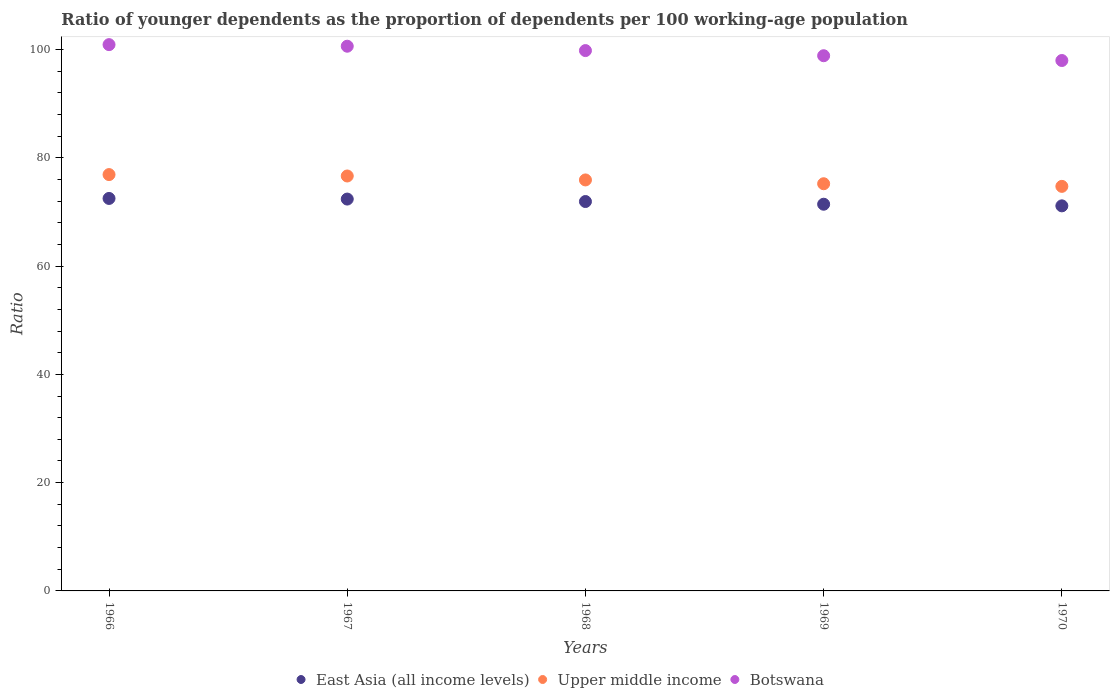Is the number of dotlines equal to the number of legend labels?
Your answer should be very brief. Yes. What is the age dependency ratio(young) in Botswana in 1969?
Your answer should be compact. 98.85. Across all years, what is the maximum age dependency ratio(young) in Botswana?
Your response must be concise. 100.9. Across all years, what is the minimum age dependency ratio(young) in East Asia (all income levels)?
Provide a succinct answer. 71.12. In which year was the age dependency ratio(young) in Upper middle income maximum?
Provide a short and direct response. 1966. In which year was the age dependency ratio(young) in East Asia (all income levels) minimum?
Your answer should be compact. 1970. What is the total age dependency ratio(young) in Botswana in the graph?
Your response must be concise. 498.14. What is the difference between the age dependency ratio(young) in Botswana in 1967 and that in 1970?
Ensure brevity in your answer.  2.64. What is the difference between the age dependency ratio(young) in East Asia (all income levels) in 1967 and the age dependency ratio(young) in Upper middle income in 1970?
Make the answer very short. -2.35. What is the average age dependency ratio(young) in East Asia (all income levels) per year?
Give a very brief answer. 71.87. In the year 1970, what is the difference between the age dependency ratio(young) in East Asia (all income levels) and age dependency ratio(young) in Botswana?
Offer a terse response. -26.85. In how many years, is the age dependency ratio(young) in Upper middle income greater than 28?
Your response must be concise. 5. What is the ratio of the age dependency ratio(young) in East Asia (all income levels) in 1967 to that in 1968?
Provide a short and direct response. 1.01. What is the difference between the highest and the second highest age dependency ratio(young) in East Asia (all income levels)?
Provide a succinct answer. 0.12. What is the difference between the highest and the lowest age dependency ratio(young) in East Asia (all income levels)?
Your answer should be compact. 1.37. Is the sum of the age dependency ratio(young) in East Asia (all income levels) in 1966 and 1970 greater than the maximum age dependency ratio(young) in Botswana across all years?
Provide a short and direct response. Yes. Is it the case that in every year, the sum of the age dependency ratio(young) in Upper middle income and age dependency ratio(young) in Botswana  is greater than the age dependency ratio(young) in East Asia (all income levels)?
Make the answer very short. Yes. How many dotlines are there?
Provide a succinct answer. 3. How many years are there in the graph?
Offer a very short reply. 5. What is the difference between two consecutive major ticks on the Y-axis?
Your response must be concise. 20. Does the graph contain grids?
Give a very brief answer. No. Where does the legend appear in the graph?
Make the answer very short. Bottom center. How are the legend labels stacked?
Give a very brief answer. Horizontal. What is the title of the graph?
Your response must be concise. Ratio of younger dependents as the proportion of dependents per 100 working-age population. Does "Dominican Republic" appear as one of the legend labels in the graph?
Offer a terse response. No. What is the label or title of the X-axis?
Your answer should be very brief. Years. What is the label or title of the Y-axis?
Offer a terse response. Ratio. What is the Ratio of East Asia (all income levels) in 1966?
Offer a very short reply. 72.49. What is the Ratio in Upper middle income in 1966?
Ensure brevity in your answer.  76.9. What is the Ratio of Botswana in 1966?
Your answer should be compact. 100.9. What is the Ratio in East Asia (all income levels) in 1967?
Make the answer very short. 72.38. What is the Ratio in Upper middle income in 1967?
Your response must be concise. 76.64. What is the Ratio in Botswana in 1967?
Provide a succinct answer. 100.61. What is the Ratio in East Asia (all income levels) in 1968?
Your answer should be compact. 71.92. What is the Ratio in Upper middle income in 1968?
Give a very brief answer. 75.91. What is the Ratio of Botswana in 1968?
Ensure brevity in your answer.  99.8. What is the Ratio in East Asia (all income levels) in 1969?
Your response must be concise. 71.43. What is the Ratio of Upper middle income in 1969?
Your answer should be compact. 75.21. What is the Ratio of Botswana in 1969?
Make the answer very short. 98.85. What is the Ratio in East Asia (all income levels) in 1970?
Give a very brief answer. 71.12. What is the Ratio of Upper middle income in 1970?
Your answer should be compact. 74.72. What is the Ratio of Botswana in 1970?
Provide a short and direct response. 97.97. Across all years, what is the maximum Ratio in East Asia (all income levels)?
Ensure brevity in your answer.  72.49. Across all years, what is the maximum Ratio of Upper middle income?
Make the answer very short. 76.9. Across all years, what is the maximum Ratio of Botswana?
Provide a succinct answer. 100.9. Across all years, what is the minimum Ratio in East Asia (all income levels)?
Your answer should be compact. 71.12. Across all years, what is the minimum Ratio of Upper middle income?
Provide a short and direct response. 74.72. Across all years, what is the minimum Ratio in Botswana?
Provide a short and direct response. 97.97. What is the total Ratio in East Asia (all income levels) in the graph?
Your answer should be very brief. 359.34. What is the total Ratio in Upper middle income in the graph?
Your answer should be very brief. 379.38. What is the total Ratio in Botswana in the graph?
Provide a succinct answer. 498.14. What is the difference between the Ratio in East Asia (all income levels) in 1966 and that in 1967?
Offer a terse response. 0.12. What is the difference between the Ratio of Upper middle income in 1966 and that in 1967?
Offer a terse response. 0.26. What is the difference between the Ratio in Botswana in 1966 and that in 1967?
Provide a succinct answer. 0.29. What is the difference between the Ratio in East Asia (all income levels) in 1966 and that in 1968?
Make the answer very short. 0.57. What is the difference between the Ratio in Upper middle income in 1966 and that in 1968?
Your response must be concise. 0.99. What is the difference between the Ratio of Botswana in 1966 and that in 1968?
Make the answer very short. 1.1. What is the difference between the Ratio in East Asia (all income levels) in 1966 and that in 1969?
Your answer should be very brief. 1.07. What is the difference between the Ratio in Upper middle income in 1966 and that in 1969?
Give a very brief answer. 1.69. What is the difference between the Ratio in Botswana in 1966 and that in 1969?
Ensure brevity in your answer.  2.05. What is the difference between the Ratio in East Asia (all income levels) in 1966 and that in 1970?
Your answer should be very brief. 1.37. What is the difference between the Ratio in Upper middle income in 1966 and that in 1970?
Keep it short and to the point. 2.18. What is the difference between the Ratio of Botswana in 1966 and that in 1970?
Your response must be concise. 2.93. What is the difference between the Ratio of East Asia (all income levels) in 1967 and that in 1968?
Your response must be concise. 0.45. What is the difference between the Ratio of Upper middle income in 1967 and that in 1968?
Your response must be concise. 0.73. What is the difference between the Ratio of Botswana in 1967 and that in 1968?
Offer a terse response. 0.81. What is the difference between the Ratio in East Asia (all income levels) in 1967 and that in 1969?
Provide a succinct answer. 0.95. What is the difference between the Ratio of Upper middle income in 1967 and that in 1969?
Offer a very short reply. 1.43. What is the difference between the Ratio in Botswana in 1967 and that in 1969?
Provide a succinct answer. 1.76. What is the difference between the Ratio of East Asia (all income levels) in 1967 and that in 1970?
Your response must be concise. 1.25. What is the difference between the Ratio in Upper middle income in 1967 and that in 1970?
Provide a succinct answer. 1.92. What is the difference between the Ratio in Botswana in 1967 and that in 1970?
Give a very brief answer. 2.64. What is the difference between the Ratio of East Asia (all income levels) in 1968 and that in 1969?
Offer a terse response. 0.5. What is the difference between the Ratio of Upper middle income in 1968 and that in 1969?
Your response must be concise. 0.7. What is the difference between the Ratio in Botswana in 1968 and that in 1969?
Offer a terse response. 0.95. What is the difference between the Ratio in East Asia (all income levels) in 1968 and that in 1970?
Provide a short and direct response. 0.8. What is the difference between the Ratio of Upper middle income in 1968 and that in 1970?
Your response must be concise. 1.19. What is the difference between the Ratio in Botswana in 1968 and that in 1970?
Your answer should be compact. 1.83. What is the difference between the Ratio of East Asia (all income levels) in 1969 and that in 1970?
Provide a succinct answer. 0.3. What is the difference between the Ratio of Upper middle income in 1969 and that in 1970?
Ensure brevity in your answer.  0.49. What is the difference between the Ratio in Botswana in 1969 and that in 1970?
Provide a succinct answer. 0.89. What is the difference between the Ratio of East Asia (all income levels) in 1966 and the Ratio of Upper middle income in 1967?
Provide a succinct answer. -4.15. What is the difference between the Ratio of East Asia (all income levels) in 1966 and the Ratio of Botswana in 1967?
Your answer should be compact. -28.12. What is the difference between the Ratio of Upper middle income in 1966 and the Ratio of Botswana in 1967?
Ensure brevity in your answer.  -23.71. What is the difference between the Ratio of East Asia (all income levels) in 1966 and the Ratio of Upper middle income in 1968?
Ensure brevity in your answer.  -3.42. What is the difference between the Ratio of East Asia (all income levels) in 1966 and the Ratio of Botswana in 1968?
Your response must be concise. -27.31. What is the difference between the Ratio of Upper middle income in 1966 and the Ratio of Botswana in 1968?
Your response must be concise. -22.9. What is the difference between the Ratio in East Asia (all income levels) in 1966 and the Ratio in Upper middle income in 1969?
Offer a terse response. -2.72. What is the difference between the Ratio in East Asia (all income levels) in 1966 and the Ratio in Botswana in 1969?
Your response must be concise. -26.36. What is the difference between the Ratio of Upper middle income in 1966 and the Ratio of Botswana in 1969?
Provide a short and direct response. -21.95. What is the difference between the Ratio in East Asia (all income levels) in 1966 and the Ratio in Upper middle income in 1970?
Your answer should be very brief. -2.23. What is the difference between the Ratio in East Asia (all income levels) in 1966 and the Ratio in Botswana in 1970?
Ensure brevity in your answer.  -25.48. What is the difference between the Ratio in Upper middle income in 1966 and the Ratio in Botswana in 1970?
Your answer should be very brief. -21.07. What is the difference between the Ratio in East Asia (all income levels) in 1967 and the Ratio in Upper middle income in 1968?
Offer a terse response. -3.53. What is the difference between the Ratio of East Asia (all income levels) in 1967 and the Ratio of Botswana in 1968?
Your response must be concise. -27.43. What is the difference between the Ratio in Upper middle income in 1967 and the Ratio in Botswana in 1968?
Offer a terse response. -23.16. What is the difference between the Ratio in East Asia (all income levels) in 1967 and the Ratio in Upper middle income in 1969?
Provide a short and direct response. -2.83. What is the difference between the Ratio in East Asia (all income levels) in 1967 and the Ratio in Botswana in 1969?
Your response must be concise. -26.48. What is the difference between the Ratio of Upper middle income in 1967 and the Ratio of Botswana in 1969?
Make the answer very short. -22.21. What is the difference between the Ratio of East Asia (all income levels) in 1967 and the Ratio of Upper middle income in 1970?
Offer a very short reply. -2.35. What is the difference between the Ratio of East Asia (all income levels) in 1967 and the Ratio of Botswana in 1970?
Make the answer very short. -25.59. What is the difference between the Ratio of Upper middle income in 1967 and the Ratio of Botswana in 1970?
Ensure brevity in your answer.  -21.33. What is the difference between the Ratio in East Asia (all income levels) in 1968 and the Ratio in Upper middle income in 1969?
Keep it short and to the point. -3.29. What is the difference between the Ratio of East Asia (all income levels) in 1968 and the Ratio of Botswana in 1969?
Provide a short and direct response. -26.93. What is the difference between the Ratio of Upper middle income in 1968 and the Ratio of Botswana in 1969?
Ensure brevity in your answer.  -22.94. What is the difference between the Ratio in East Asia (all income levels) in 1968 and the Ratio in Upper middle income in 1970?
Provide a succinct answer. -2.8. What is the difference between the Ratio of East Asia (all income levels) in 1968 and the Ratio of Botswana in 1970?
Make the answer very short. -26.05. What is the difference between the Ratio in Upper middle income in 1968 and the Ratio in Botswana in 1970?
Offer a terse response. -22.06. What is the difference between the Ratio of East Asia (all income levels) in 1969 and the Ratio of Upper middle income in 1970?
Your answer should be very brief. -3.3. What is the difference between the Ratio in East Asia (all income levels) in 1969 and the Ratio in Botswana in 1970?
Offer a terse response. -26.54. What is the difference between the Ratio in Upper middle income in 1969 and the Ratio in Botswana in 1970?
Offer a terse response. -22.76. What is the average Ratio in East Asia (all income levels) per year?
Your answer should be compact. 71.87. What is the average Ratio of Upper middle income per year?
Ensure brevity in your answer.  75.88. What is the average Ratio in Botswana per year?
Keep it short and to the point. 99.63. In the year 1966, what is the difference between the Ratio in East Asia (all income levels) and Ratio in Upper middle income?
Keep it short and to the point. -4.41. In the year 1966, what is the difference between the Ratio of East Asia (all income levels) and Ratio of Botswana?
Give a very brief answer. -28.41. In the year 1966, what is the difference between the Ratio of Upper middle income and Ratio of Botswana?
Your answer should be very brief. -24. In the year 1967, what is the difference between the Ratio of East Asia (all income levels) and Ratio of Upper middle income?
Your answer should be very brief. -4.26. In the year 1967, what is the difference between the Ratio of East Asia (all income levels) and Ratio of Botswana?
Offer a terse response. -28.23. In the year 1967, what is the difference between the Ratio in Upper middle income and Ratio in Botswana?
Offer a terse response. -23.97. In the year 1968, what is the difference between the Ratio of East Asia (all income levels) and Ratio of Upper middle income?
Offer a terse response. -3.99. In the year 1968, what is the difference between the Ratio of East Asia (all income levels) and Ratio of Botswana?
Keep it short and to the point. -27.88. In the year 1968, what is the difference between the Ratio of Upper middle income and Ratio of Botswana?
Your response must be concise. -23.89. In the year 1969, what is the difference between the Ratio in East Asia (all income levels) and Ratio in Upper middle income?
Provide a succinct answer. -3.78. In the year 1969, what is the difference between the Ratio in East Asia (all income levels) and Ratio in Botswana?
Provide a short and direct response. -27.43. In the year 1969, what is the difference between the Ratio of Upper middle income and Ratio of Botswana?
Offer a terse response. -23.65. In the year 1970, what is the difference between the Ratio in East Asia (all income levels) and Ratio in Upper middle income?
Provide a short and direct response. -3.6. In the year 1970, what is the difference between the Ratio in East Asia (all income levels) and Ratio in Botswana?
Give a very brief answer. -26.85. In the year 1970, what is the difference between the Ratio in Upper middle income and Ratio in Botswana?
Your answer should be very brief. -23.25. What is the ratio of the Ratio of Botswana in 1966 to that in 1967?
Your answer should be compact. 1. What is the ratio of the Ratio of East Asia (all income levels) in 1966 to that in 1968?
Provide a short and direct response. 1.01. What is the ratio of the Ratio in East Asia (all income levels) in 1966 to that in 1969?
Give a very brief answer. 1.01. What is the ratio of the Ratio of Upper middle income in 1966 to that in 1969?
Offer a very short reply. 1.02. What is the ratio of the Ratio of Botswana in 1966 to that in 1969?
Ensure brevity in your answer.  1.02. What is the ratio of the Ratio of East Asia (all income levels) in 1966 to that in 1970?
Offer a terse response. 1.02. What is the ratio of the Ratio in Upper middle income in 1966 to that in 1970?
Provide a short and direct response. 1.03. What is the ratio of the Ratio in Botswana in 1966 to that in 1970?
Keep it short and to the point. 1.03. What is the ratio of the Ratio in Upper middle income in 1967 to that in 1968?
Give a very brief answer. 1.01. What is the ratio of the Ratio in East Asia (all income levels) in 1967 to that in 1969?
Make the answer very short. 1.01. What is the ratio of the Ratio in Botswana in 1967 to that in 1969?
Offer a very short reply. 1.02. What is the ratio of the Ratio in East Asia (all income levels) in 1967 to that in 1970?
Provide a short and direct response. 1.02. What is the ratio of the Ratio in Upper middle income in 1967 to that in 1970?
Ensure brevity in your answer.  1.03. What is the ratio of the Ratio of Botswana in 1967 to that in 1970?
Your answer should be compact. 1.03. What is the ratio of the Ratio of Upper middle income in 1968 to that in 1969?
Your response must be concise. 1.01. What is the ratio of the Ratio of Botswana in 1968 to that in 1969?
Offer a very short reply. 1.01. What is the ratio of the Ratio of East Asia (all income levels) in 1968 to that in 1970?
Provide a succinct answer. 1.01. What is the ratio of the Ratio in Upper middle income in 1968 to that in 1970?
Your answer should be very brief. 1.02. What is the ratio of the Ratio of Botswana in 1968 to that in 1970?
Make the answer very short. 1.02. What is the ratio of the Ratio of East Asia (all income levels) in 1969 to that in 1970?
Ensure brevity in your answer.  1. What is the ratio of the Ratio in Upper middle income in 1969 to that in 1970?
Give a very brief answer. 1.01. What is the difference between the highest and the second highest Ratio of East Asia (all income levels)?
Provide a short and direct response. 0.12. What is the difference between the highest and the second highest Ratio of Upper middle income?
Your answer should be very brief. 0.26. What is the difference between the highest and the second highest Ratio of Botswana?
Offer a very short reply. 0.29. What is the difference between the highest and the lowest Ratio in East Asia (all income levels)?
Your answer should be very brief. 1.37. What is the difference between the highest and the lowest Ratio in Upper middle income?
Offer a very short reply. 2.18. What is the difference between the highest and the lowest Ratio of Botswana?
Provide a succinct answer. 2.93. 